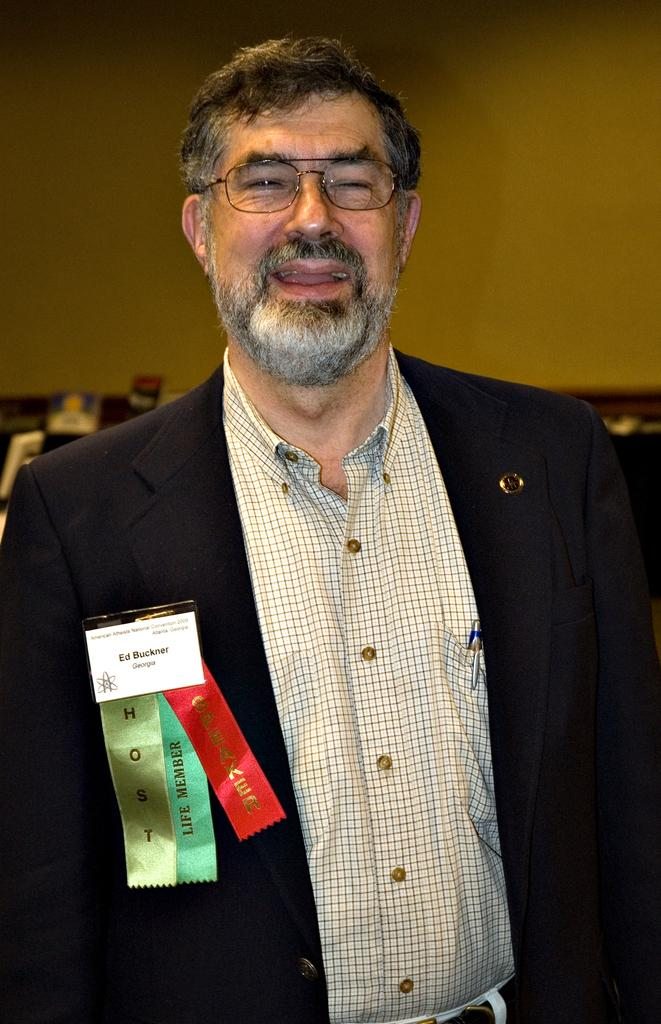What is the main subject of the image? There is a person standing in the image. Can you describe the person's appearance? The person is wearing spectacles. What can be seen in the background of the image? There are photo frames and a wall visible in the background. What type of pump is being used in the battle depicted in the image? There is no battle or pump present in the image; it features a person standing with spectacles and a background of photo frames and a wall. 